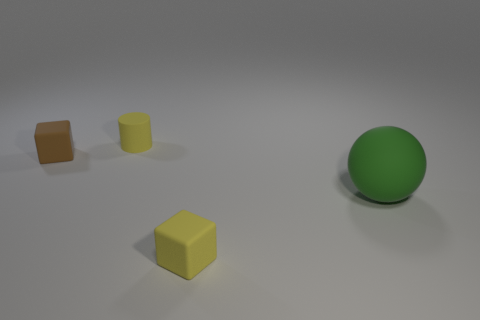Add 1 large blue rubber objects. How many objects exist? 5 Subtract all balls. How many objects are left? 3 Add 1 tiny yellow things. How many tiny yellow things are left? 3 Add 3 large gray rubber balls. How many large gray rubber balls exist? 3 Subtract 0 green cylinders. How many objects are left? 4 Subtract all blocks. Subtract all small blue shiny blocks. How many objects are left? 2 